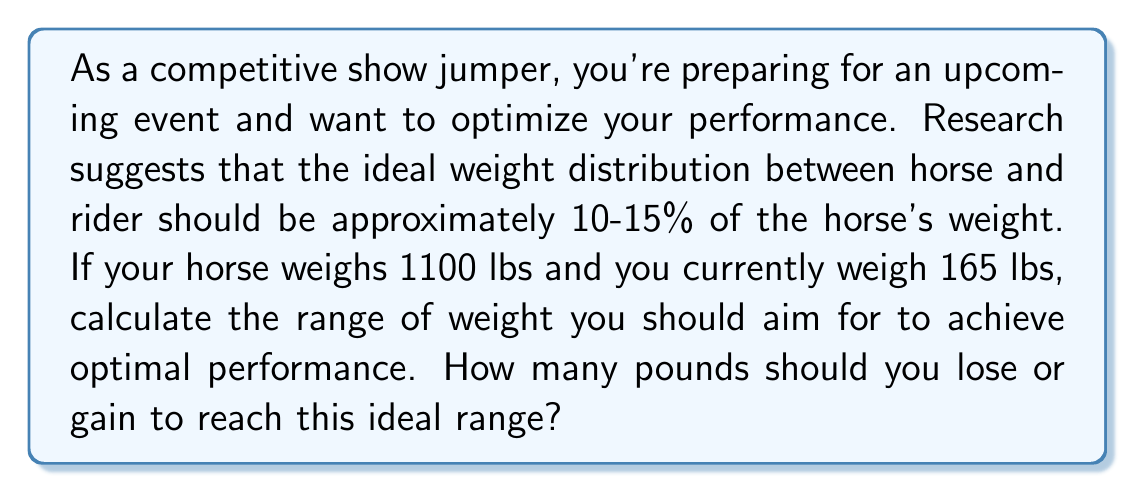What is the answer to this math problem? Let's approach this problem step-by-step:

1. First, we need to calculate the ideal weight range for the rider based on the horse's weight:

   Lower bound: $0.10 \times 1100 = 110$ lbs
   Upper bound: $0.15 \times 1100 = 165$ lbs

2. The ideal weight range for the rider is 110-165 lbs.

3. The rider's current weight is 165 lbs, which is at the upper limit of the ideal range.

4. To calculate the range of weight change needed:
   
   Minimum change: $165 - 165 = 0$ lbs (no change needed)
   Maximum change: $165 - 110 = 55$ lbs (maximum weight loss)

5. The optimal weight range can be expressed as:

   $$165 - x, \text{ where } 0 \leq x \leq 55$$

This means the rider could lose up to 55 lbs to stay within the ideal weight range, but doesn't need to lose any weight to be at the upper limit of the range.
Answer: The rider should aim to maintain their current weight or lose up to 55 lbs to achieve the ideal weight distribution. The optimal weight range is $165 - x$ lbs, where $0 \leq x \leq 55$. 